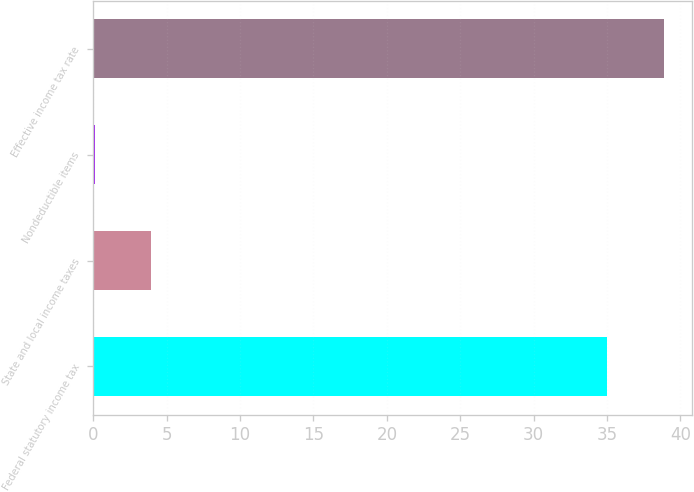<chart> <loc_0><loc_0><loc_500><loc_500><bar_chart><fcel>Federal statutory income tax<fcel>State and local income taxes<fcel>Nondeductible items<fcel>Effective income tax rate<nl><fcel>35<fcel>3.95<fcel>0.1<fcel>38.85<nl></chart> 